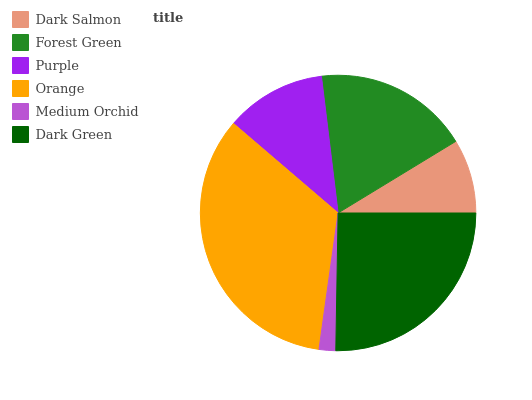Is Medium Orchid the minimum?
Answer yes or no. Yes. Is Orange the maximum?
Answer yes or no. Yes. Is Forest Green the minimum?
Answer yes or no. No. Is Forest Green the maximum?
Answer yes or no. No. Is Forest Green greater than Dark Salmon?
Answer yes or no. Yes. Is Dark Salmon less than Forest Green?
Answer yes or no. Yes. Is Dark Salmon greater than Forest Green?
Answer yes or no. No. Is Forest Green less than Dark Salmon?
Answer yes or no. No. Is Forest Green the high median?
Answer yes or no. Yes. Is Purple the low median?
Answer yes or no. Yes. Is Orange the high median?
Answer yes or no. No. Is Dark Green the low median?
Answer yes or no. No. 